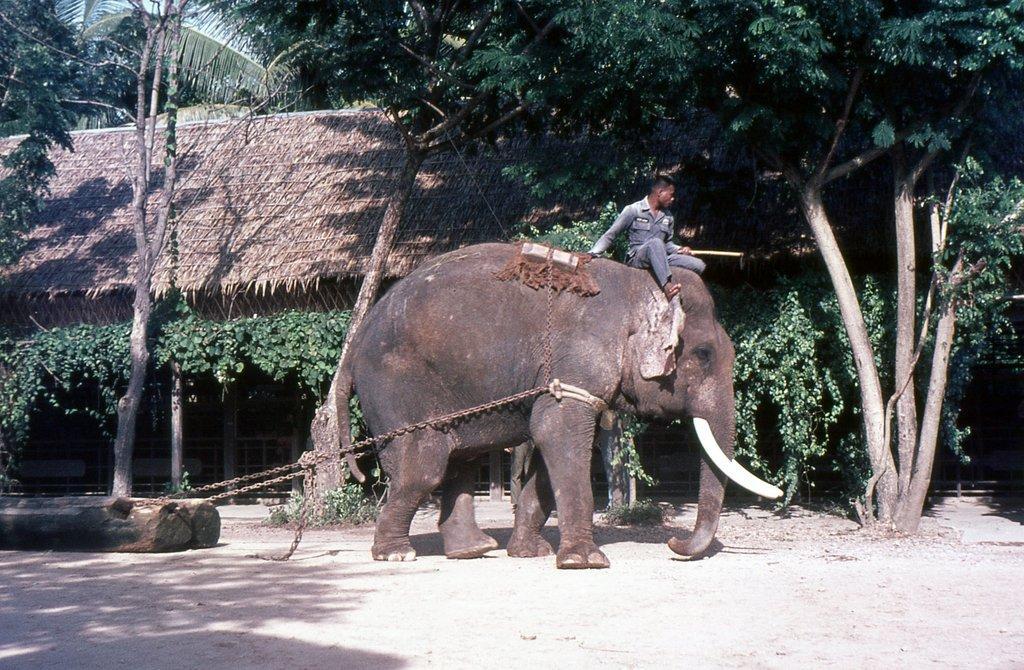How would you summarize this image in a sentence or two? In this image, at the middle we can see an elephant, there is a man sitting on the elephant, in the background there are some green color trees. 